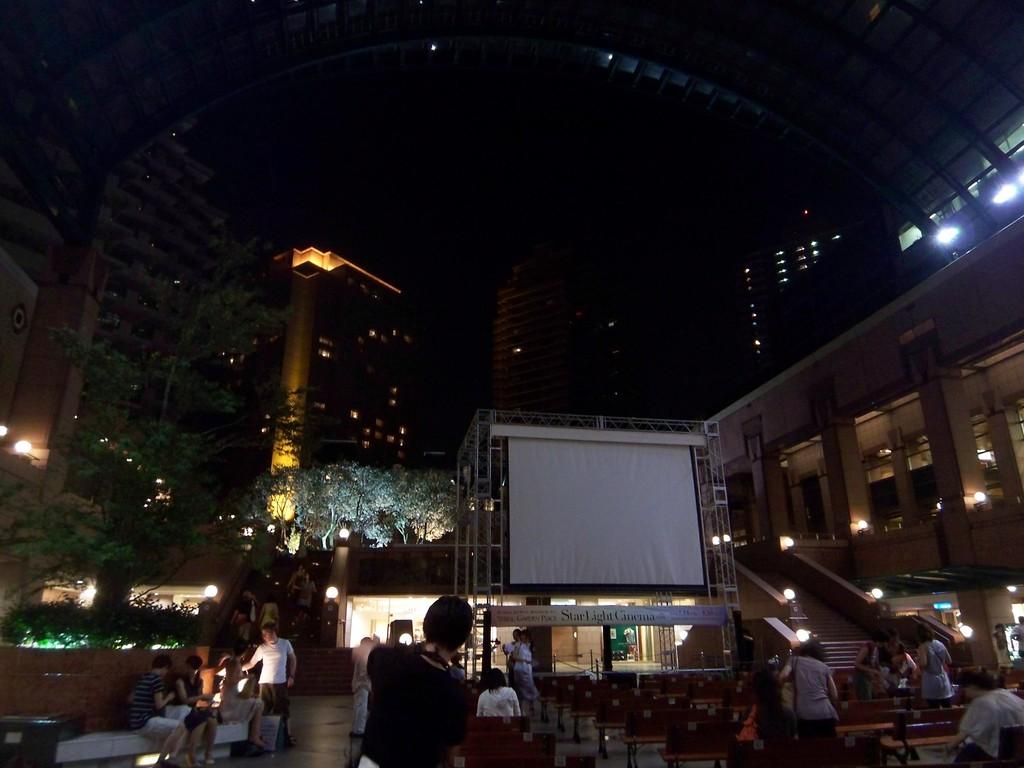What is located in the foreground of the image? There are people in the foreground of the image. What can be seen in the image besides the people? There is a screen and buildings in the background of the image. What type of vegetation is visible in the background of the image? There are trees in the background of the image. Where is the cushion placed in the image? There is no cushion present in the image. What type of lead is being used by the people in the image? There is no indication of any lead being used by the people in the image. 